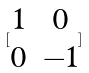Convert formula to latex. <formula><loc_0><loc_0><loc_500><loc_500>[ \begin{matrix} 1 & 0 \\ 0 & - 1 \end{matrix} ]</formula> 